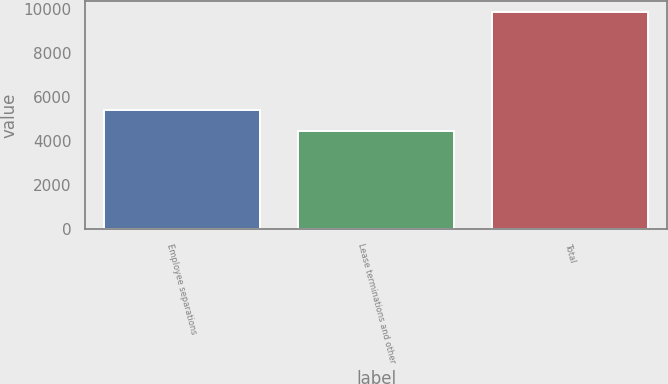Convert chart. <chart><loc_0><loc_0><loc_500><loc_500><bar_chart><fcel>Employee separations<fcel>Lease terminations and other<fcel>Total<nl><fcel>5399<fcel>4453<fcel>9852<nl></chart> 